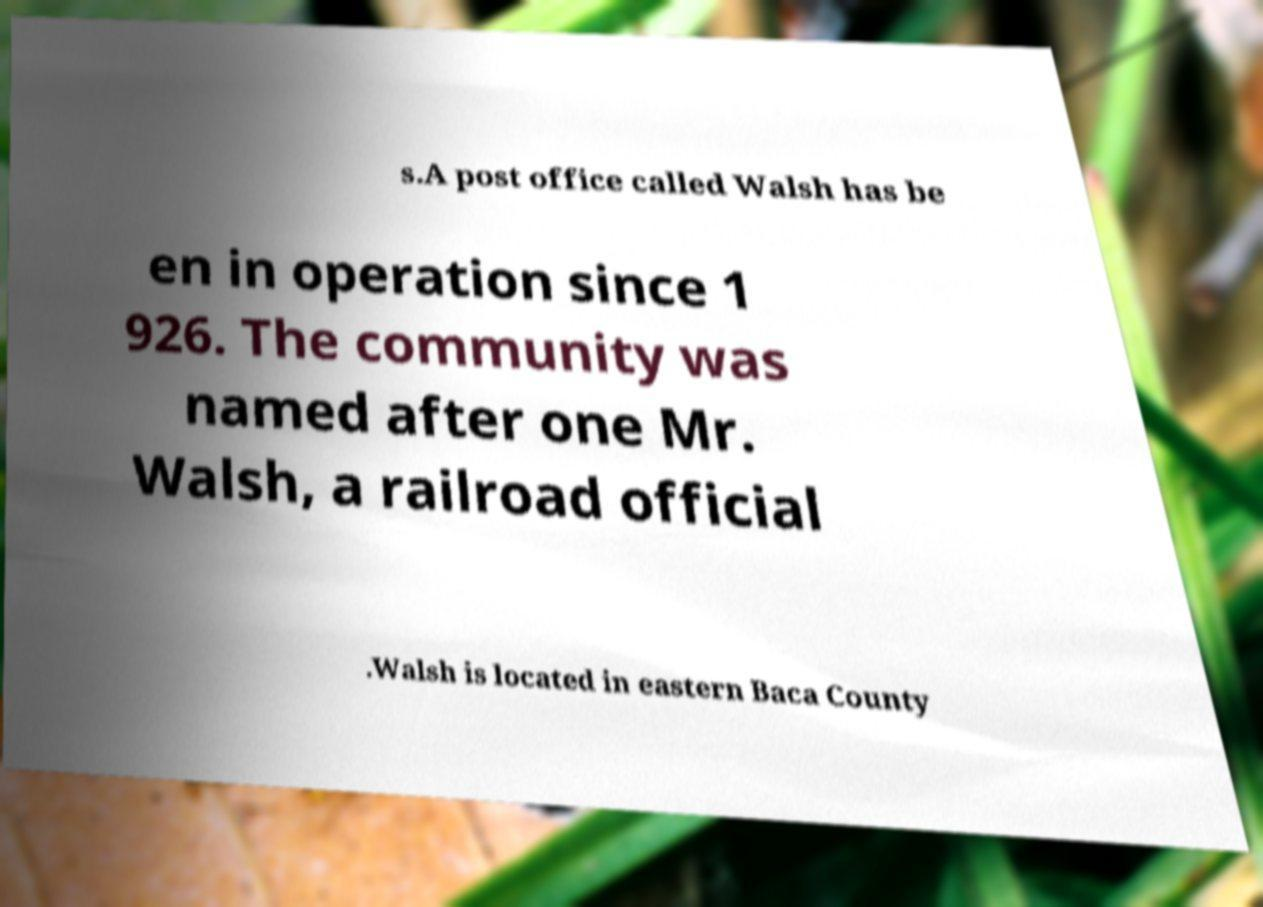Please read and relay the text visible in this image. What does it say? s.A post office called Walsh has be en in operation since 1 926. The community was named after one Mr. Walsh, a railroad official .Walsh is located in eastern Baca County 